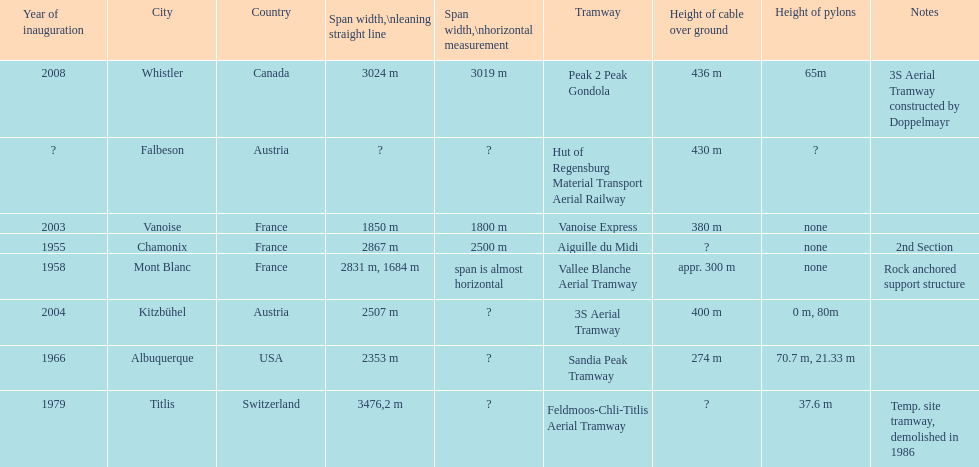How many aerial tramways are located in france? 3. 